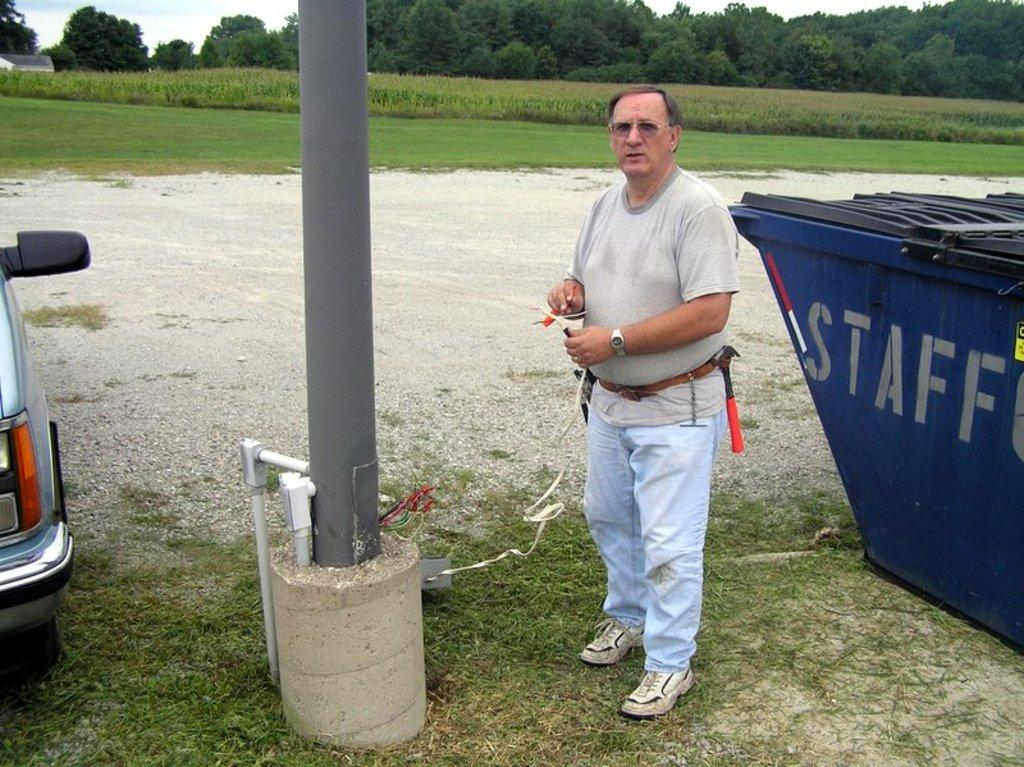<image>
Render a clear and concise summary of the photo. A man standing in front of a dumpster labled staff. 